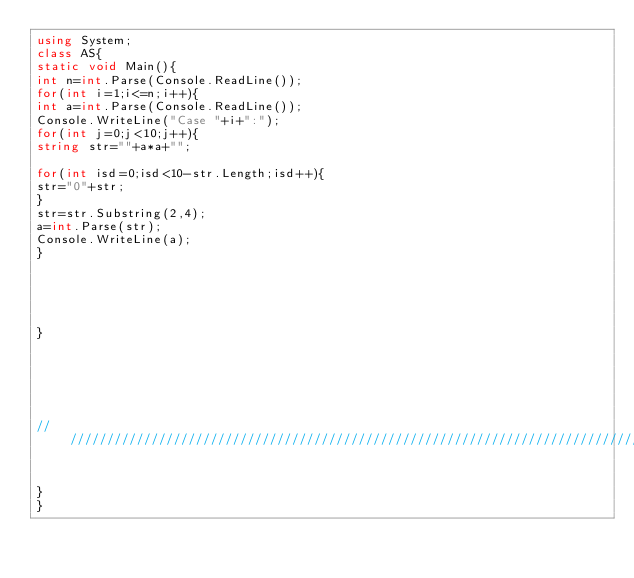Convert code to text. <code><loc_0><loc_0><loc_500><loc_500><_C#_>using System;
class AS{
static void Main(){
int n=int.Parse(Console.ReadLine());
for(int i=1;i<=n;i++){
int a=int.Parse(Console.ReadLine());
Console.WriteLine("Case "+i+":");
for(int j=0;j<10;j++){
string str=""+a*a+"";
 
for(int isd=0;isd<10-str.Length;isd++){
str="0"+str;
}
str=str.Substring(2,4);
a=int.Parse(str);
Console.WriteLine(a);
}
 
 
 
 
 
}
 
 
 
 
 
 
/////////////////////////////////////////////////////////////////////////////////////////////////////
 
 
}
}</code> 